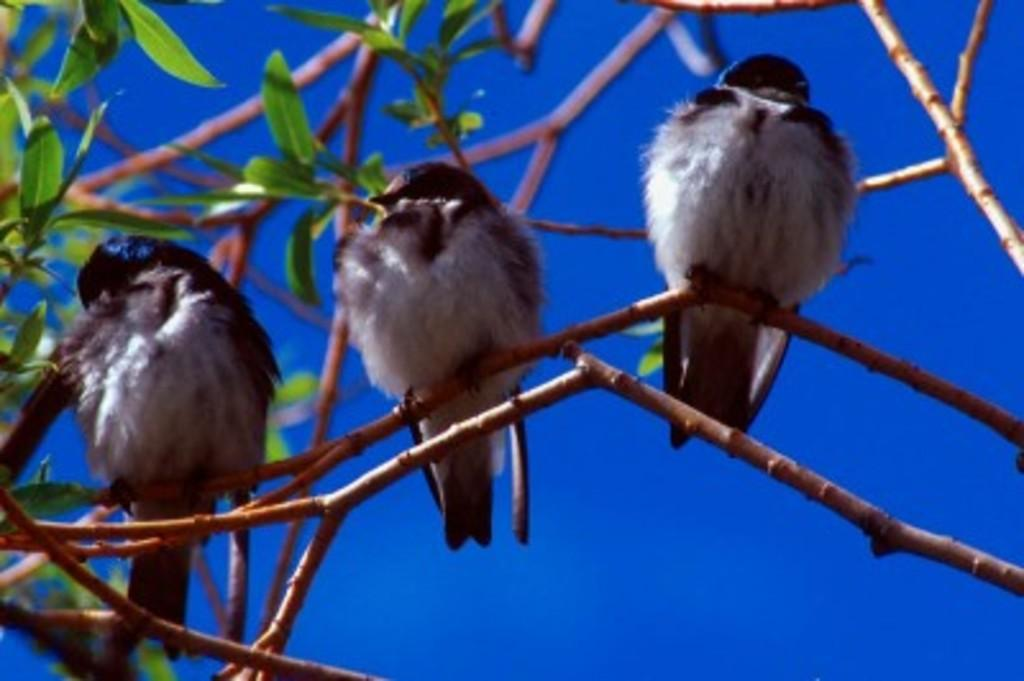How many birds are in the image? There are three birds in the image. Where are the birds located? The birds are on a branch of a tree. What can be seen in the background of the image? The sky is visible in the background of the image. What type of hill can be seen in the image? There is no hill present in the image; it features three birds on a tree branch with a visible sky in the background. 